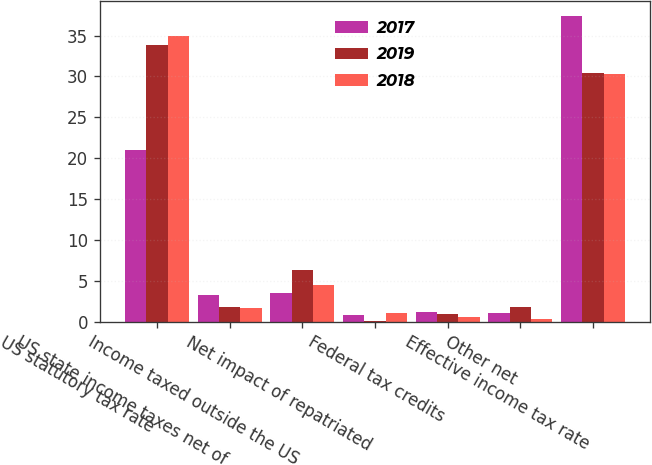Convert chart. <chart><loc_0><loc_0><loc_500><loc_500><stacked_bar_chart><ecel><fcel>US statutory tax rate<fcel>US state income taxes net of<fcel>Income taxed outside the US<fcel>Net impact of repatriated<fcel>Federal tax credits<fcel>Other net<fcel>Effective income tax rate<nl><fcel>2017<fcel>21<fcel>3.3<fcel>3.5<fcel>0.8<fcel>1.2<fcel>1<fcel>37.4<nl><fcel>2019<fcel>33.8<fcel>1.8<fcel>6.3<fcel>0.1<fcel>0.9<fcel>1.8<fcel>30.4<nl><fcel>2018<fcel>35<fcel>1.7<fcel>4.5<fcel>1<fcel>0.6<fcel>0.3<fcel>30.3<nl></chart> 